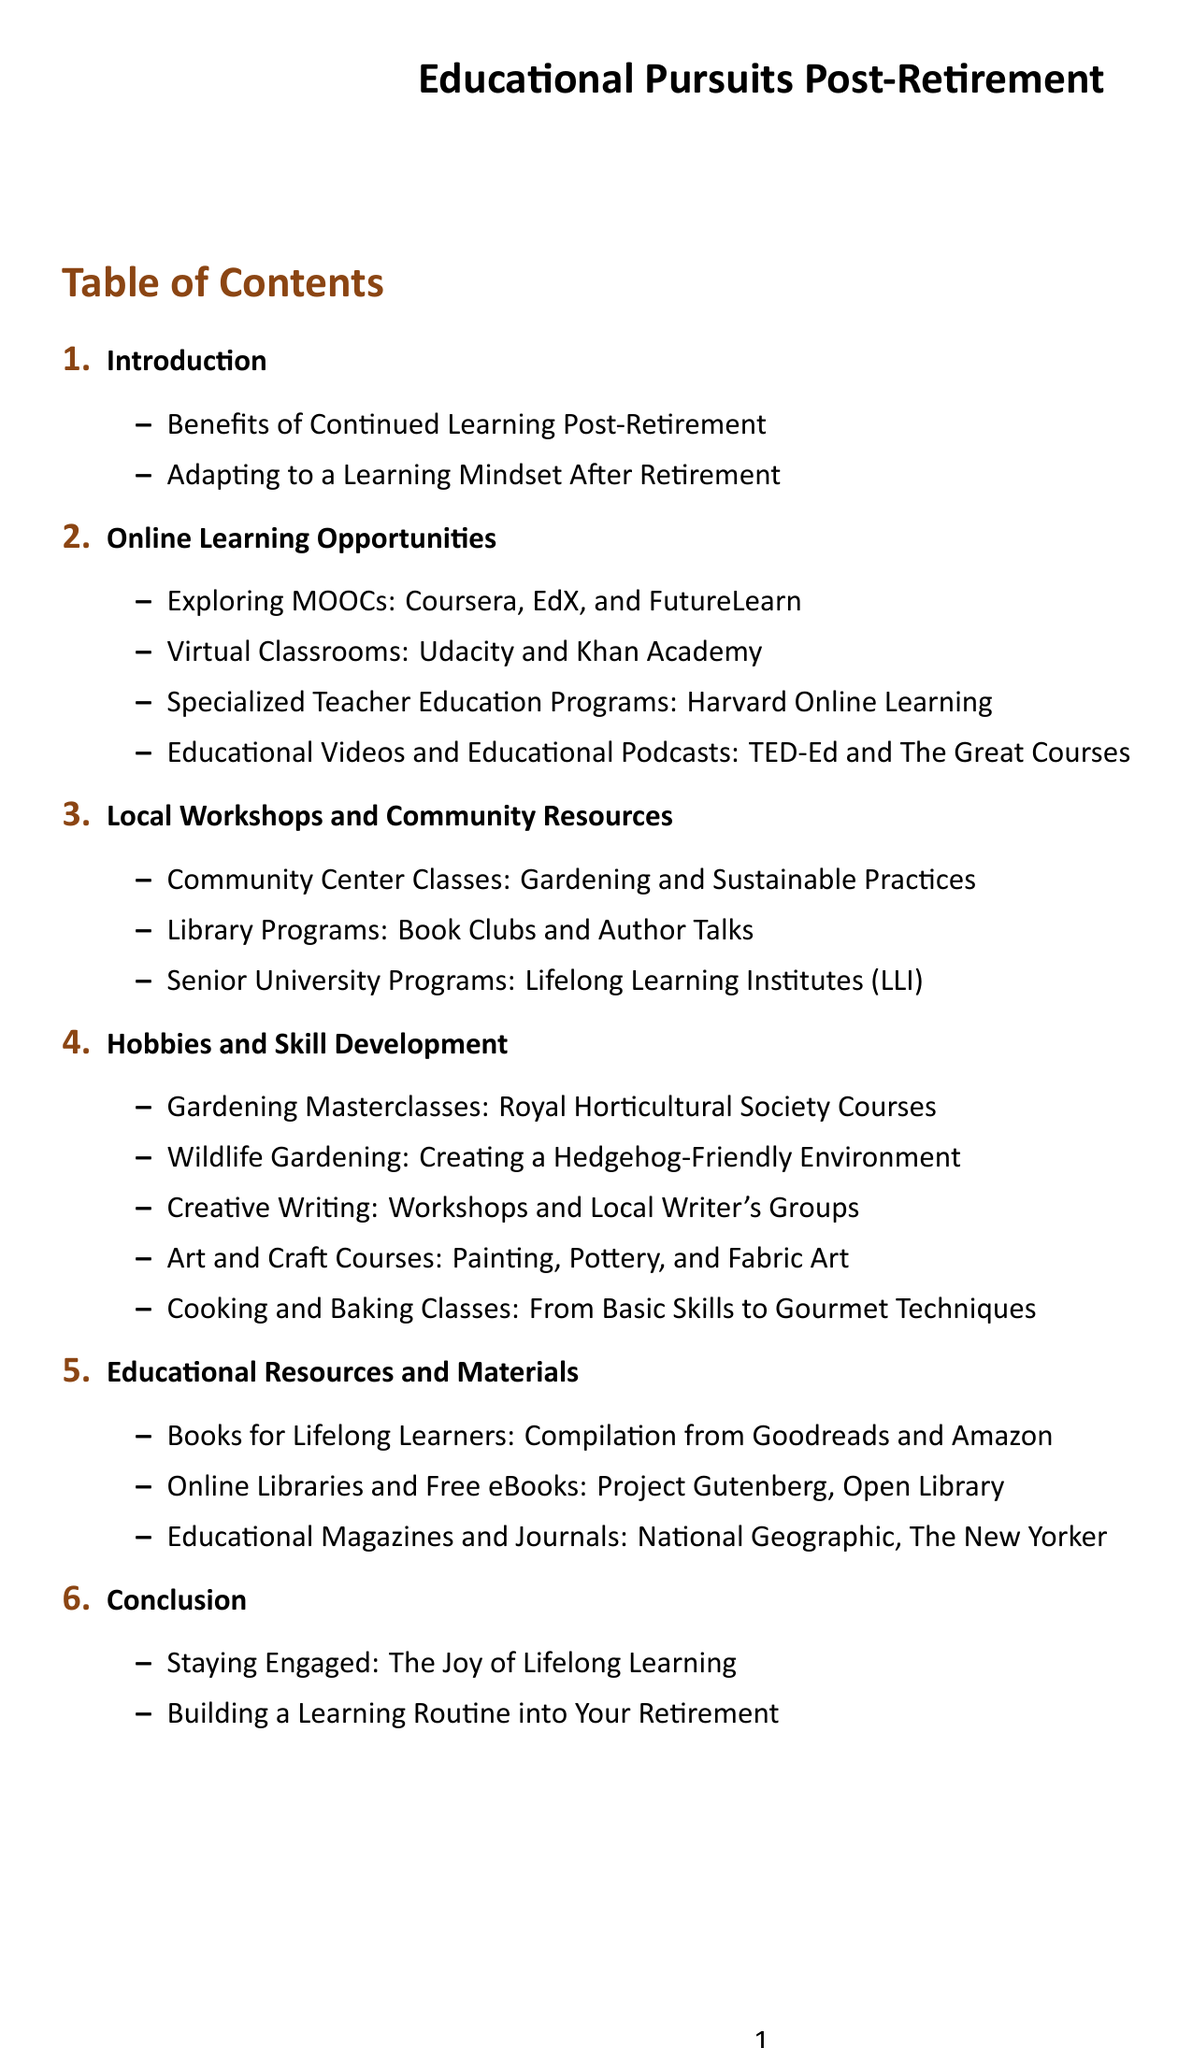What is the first section title? The first section title listed in the table of contents is "Introduction."
Answer: Introduction How many main sections are there in the document? There are a total of six main sections listed in the table of contents.
Answer: 6 What online learning platform is mentioned first? The first online learning platform mentioned in the document is "Coursera."
Answer: Coursera Which community resource is focused on local book discussions? The community resource focused on local book discussions is "Library Programs."
Answer: Library Programs What hobby-related course is highlighted under skill development? One highlighted hobby-related course is "Gardening Masterclasses."
Answer: Gardening Masterclasses What is the last topic covered in the conclusion section? The last topic covered in the conclusion section is "Building a Learning Routine into Your Retirement."
Answer: Building a Learning Routine into Your Retirement What type of classes does the "Community Center" offer? The community center offers "Gardening and Sustainable Practices" classes.
Answer: Gardening and Sustainable Practices How many online learning opportunities are listed? There are four online learning opportunities listed in the document.
Answer: 4 